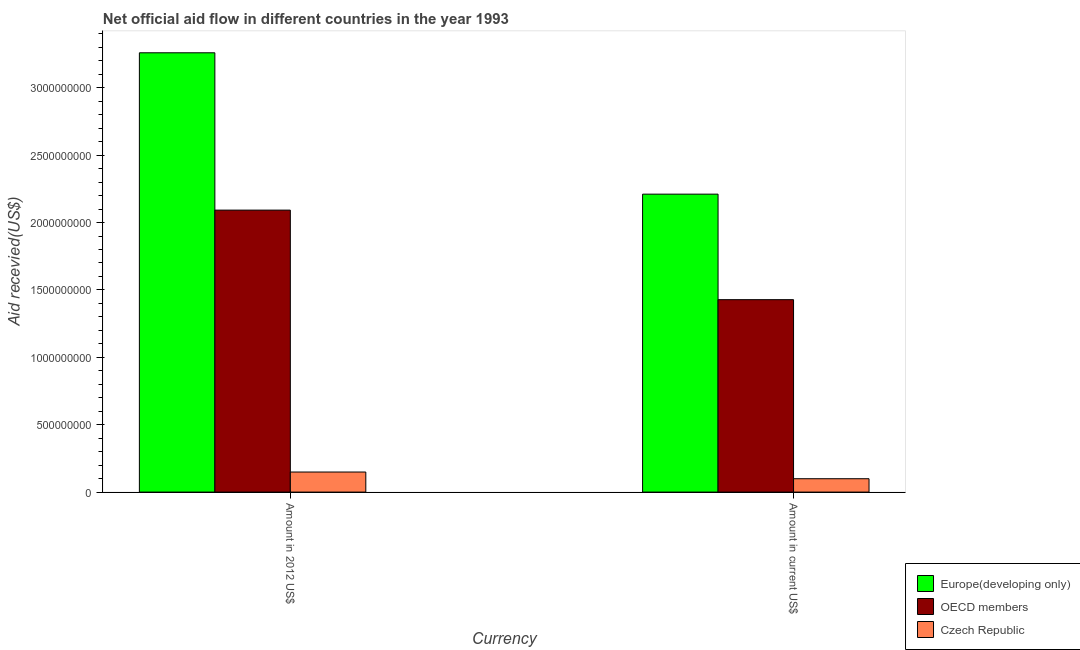How many different coloured bars are there?
Offer a very short reply. 3. How many groups of bars are there?
Keep it short and to the point. 2. Are the number of bars per tick equal to the number of legend labels?
Make the answer very short. Yes. How many bars are there on the 1st tick from the left?
Ensure brevity in your answer.  3. What is the label of the 2nd group of bars from the left?
Offer a terse response. Amount in current US$. What is the amount of aid received(expressed in 2012 us$) in OECD members?
Keep it short and to the point. 2.09e+09. Across all countries, what is the maximum amount of aid received(expressed in us$)?
Offer a very short reply. 2.21e+09. Across all countries, what is the minimum amount of aid received(expressed in us$)?
Give a very brief answer. 9.92e+07. In which country was the amount of aid received(expressed in 2012 us$) maximum?
Your response must be concise. Europe(developing only). In which country was the amount of aid received(expressed in us$) minimum?
Keep it short and to the point. Czech Republic. What is the total amount of aid received(expressed in us$) in the graph?
Keep it short and to the point. 3.74e+09. What is the difference between the amount of aid received(expressed in us$) in Czech Republic and that in OECD members?
Your answer should be very brief. -1.33e+09. What is the difference between the amount of aid received(expressed in 2012 us$) in OECD members and the amount of aid received(expressed in us$) in Czech Republic?
Make the answer very short. 1.99e+09. What is the average amount of aid received(expressed in 2012 us$) per country?
Make the answer very short. 1.83e+09. What is the difference between the amount of aid received(expressed in 2012 us$) and amount of aid received(expressed in us$) in Europe(developing only)?
Offer a terse response. 1.05e+09. In how many countries, is the amount of aid received(expressed in 2012 us$) greater than 2600000000 US$?
Ensure brevity in your answer.  1. What is the ratio of the amount of aid received(expressed in 2012 us$) in Europe(developing only) to that in OECD members?
Your response must be concise. 1.56. What does the 3rd bar from the right in Amount in 2012 US$ represents?
Make the answer very short. Europe(developing only). What is the difference between two consecutive major ticks on the Y-axis?
Offer a very short reply. 5.00e+08. Are the values on the major ticks of Y-axis written in scientific E-notation?
Your answer should be compact. No. Does the graph contain any zero values?
Offer a terse response. No. Does the graph contain grids?
Ensure brevity in your answer.  No. Where does the legend appear in the graph?
Your answer should be compact. Bottom right. How many legend labels are there?
Offer a terse response. 3. What is the title of the graph?
Your answer should be very brief. Net official aid flow in different countries in the year 1993. What is the label or title of the X-axis?
Give a very brief answer. Currency. What is the label or title of the Y-axis?
Provide a short and direct response. Aid recevied(US$). What is the Aid recevied(US$) in Europe(developing only) in Amount in 2012 US$?
Offer a terse response. 3.26e+09. What is the Aid recevied(US$) of OECD members in Amount in 2012 US$?
Offer a very short reply. 2.09e+09. What is the Aid recevied(US$) of Czech Republic in Amount in 2012 US$?
Your answer should be very brief. 1.49e+08. What is the Aid recevied(US$) of Europe(developing only) in Amount in current US$?
Your response must be concise. 2.21e+09. What is the Aid recevied(US$) in OECD members in Amount in current US$?
Your answer should be very brief. 1.43e+09. What is the Aid recevied(US$) of Czech Republic in Amount in current US$?
Give a very brief answer. 9.92e+07. Across all Currency, what is the maximum Aid recevied(US$) in Europe(developing only)?
Provide a succinct answer. 3.26e+09. Across all Currency, what is the maximum Aid recevied(US$) of OECD members?
Provide a short and direct response. 2.09e+09. Across all Currency, what is the maximum Aid recevied(US$) of Czech Republic?
Keep it short and to the point. 1.49e+08. Across all Currency, what is the minimum Aid recevied(US$) of Europe(developing only)?
Keep it short and to the point. 2.21e+09. Across all Currency, what is the minimum Aid recevied(US$) of OECD members?
Give a very brief answer. 1.43e+09. Across all Currency, what is the minimum Aid recevied(US$) in Czech Republic?
Provide a succinct answer. 9.92e+07. What is the total Aid recevied(US$) of Europe(developing only) in the graph?
Offer a very short reply. 5.47e+09. What is the total Aid recevied(US$) in OECD members in the graph?
Your answer should be compact. 3.52e+09. What is the total Aid recevied(US$) in Czech Republic in the graph?
Ensure brevity in your answer.  2.48e+08. What is the difference between the Aid recevied(US$) of Europe(developing only) in Amount in 2012 US$ and that in Amount in current US$?
Offer a very short reply. 1.05e+09. What is the difference between the Aid recevied(US$) in OECD members in Amount in 2012 US$ and that in Amount in current US$?
Ensure brevity in your answer.  6.65e+08. What is the difference between the Aid recevied(US$) of Czech Republic in Amount in 2012 US$ and that in Amount in current US$?
Your answer should be very brief. 4.97e+07. What is the difference between the Aid recevied(US$) in Europe(developing only) in Amount in 2012 US$ and the Aid recevied(US$) in OECD members in Amount in current US$?
Offer a terse response. 1.83e+09. What is the difference between the Aid recevied(US$) in Europe(developing only) in Amount in 2012 US$ and the Aid recevied(US$) in Czech Republic in Amount in current US$?
Provide a succinct answer. 3.16e+09. What is the difference between the Aid recevied(US$) in OECD members in Amount in 2012 US$ and the Aid recevied(US$) in Czech Republic in Amount in current US$?
Give a very brief answer. 1.99e+09. What is the average Aid recevied(US$) in Europe(developing only) per Currency?
Ensure brevity in your answer.  2.74e+09. What is the average Aid recevied(US$) in OECD members per Currency?
Your answer should be compact. 1.76e+09. What is the average Aid recevied(US$) of Czech Republic per Currency?
Offer a terse response. 1.24e+08. What is the difference between the Aid recevied(US$) of Europe(developing only) and Aid recevied(US$) of OECD members in Amount in 2012 US$?
Keep it short and to the point. 1.17e+09. What is the difference between the Aid recevied(US$) in Europe(developing only) and Aid recevied(US$) in Czech Republic in Amount in 2012 US$?
Your response must be concise. 3.11e+09. What is the difference between the Aid recevied(US$) of OECD members and Aid recevied(US$) of Czech Republic in Amount in 2012 US$?
Your answer should be very brief. 1.94e+09. What is the difference between the Aid recevied(US$) in Europe(developing only) and Aid recevied(US$) in OECD members in Amount in current US$?
Offer a very short reply. 7.83e+08. What is the difference between the Aid recevied(US$) in Europe(developing only) and Aid recevied(US$) in Czech Republic in Amount in current US$?
Your response must be concise. 2.11e+09. What is the difference between the Aid recevied(US$) in OECD members and Aid recevied(US$) in Czech Republic in Amount in current US$?
Keep it short and to the point. 1.33e+09. What is the ratio of the Aid recevied(US$) of Europe(developing only) in Amount in 2012 US$ to that in Amount in current US$?
Make the answer very short. 1.47. What is the ratio of the Aid recevied(US$) in OECD members in Amount in 2012 US$ to that in Amount in current US$?
Keep it short and to the point. 1.47. What is the ratio of the Aid recevied(US$) of Czech Republic in Amount in 2012 US$ to that in Amount in current US$?
Provide a short and direct response. 1.5. What is the difference between the highest and the second highest Aid recevied(US$) of Europe(developing only)?
Give a very brief answer. 1.05e+09. What is the difference between the highest and the second highest Aid recevied(US$) of OECD members?
Ensure brevity in your answer.  6.65e+08. What is the difference between the highest and the second highest Aid recevied(US$) of Czech Republic?
Give a very brief answer. 4.97e+07. What is the difference between the highest and the lowest Aid recevied(US$) in Europe(developing only)?
Make the answer very short. 1.05e+09. What is the difference between the highest and the lowest Aid recevied(US$) of OECD members?
Your answer should be compact. 6.65e+08. What is the difference between the highest and the lowest Aid recevied(US$) in Czech Republic?
Your answer should be compact. 4.97e+07. 